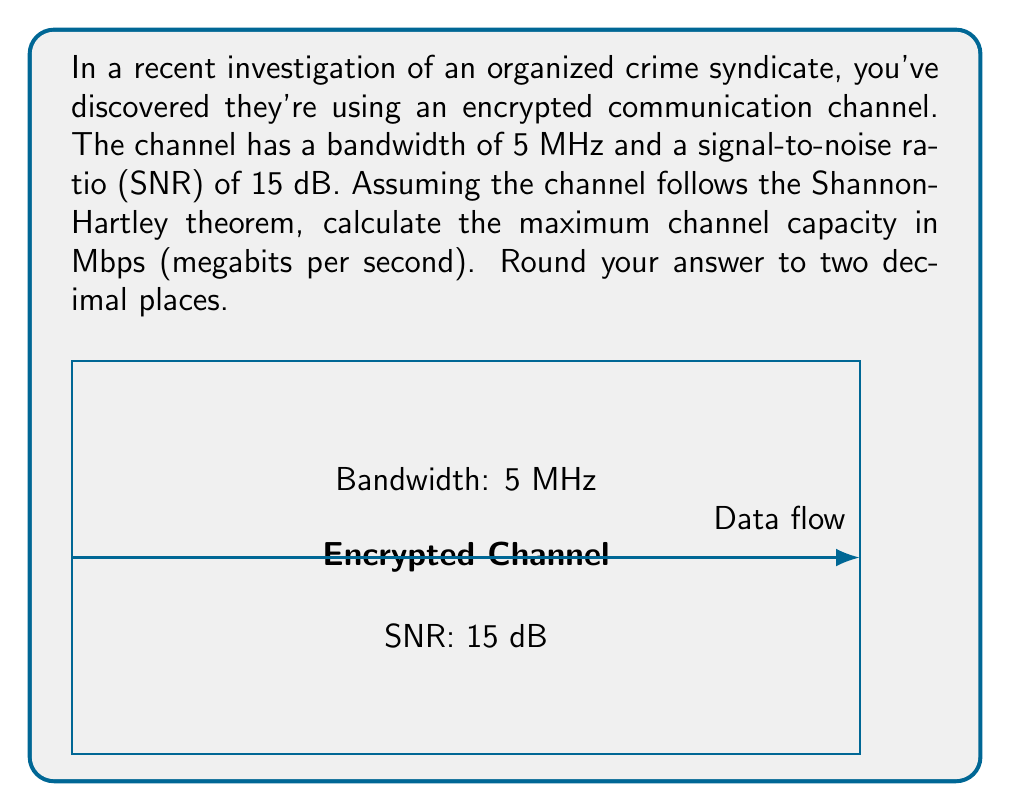Show me your answer to this math problem. To solve this problem, we'll use the Shannon-Hartley theorem, which gives the channel capacity for a noisy channel. The steps are as follows:

1) The Shannon-Hartley theorem states that the channel capacity $C$ is:

   $$C = B \log_2(1 + SNR)$$

   where $B$ is the bandwidth in Hz and SNR is the signal-to-noise ratio.

2) We're given:
   - Bandwidth $B = 5$ MHz = $5 \times 10^6$ Hz
   - SNR = 15 dB

3) We need to convert the SNR from dB to a linear scale:
   $$SNR_{linear} = 10^{SNR_{dB}/10} = 10^{15/10} = 10^{1.5} \approx 31.6228$$

4) Now we can plug these values into the Shannon-Hartley equation:

   $$C = (5 \times 10^6) \log_2(1 + 31.6228)$$

5) Calculate:
   $$C = (5 \times 10^6) \log_2(32.6228)$$
   $$C = (5 \times 10^6) (5.0279)$$
   $$C = 25,139,500 \text{ bits per second}$$

6) Convert to Mbps:
   $$C = 25.1395 \text{ Mbps}$$

7) Rounding to two decimal places:
   $$C \approx 25.14 \text{ Mbps}$$
Answer: 25.14 Mbps 